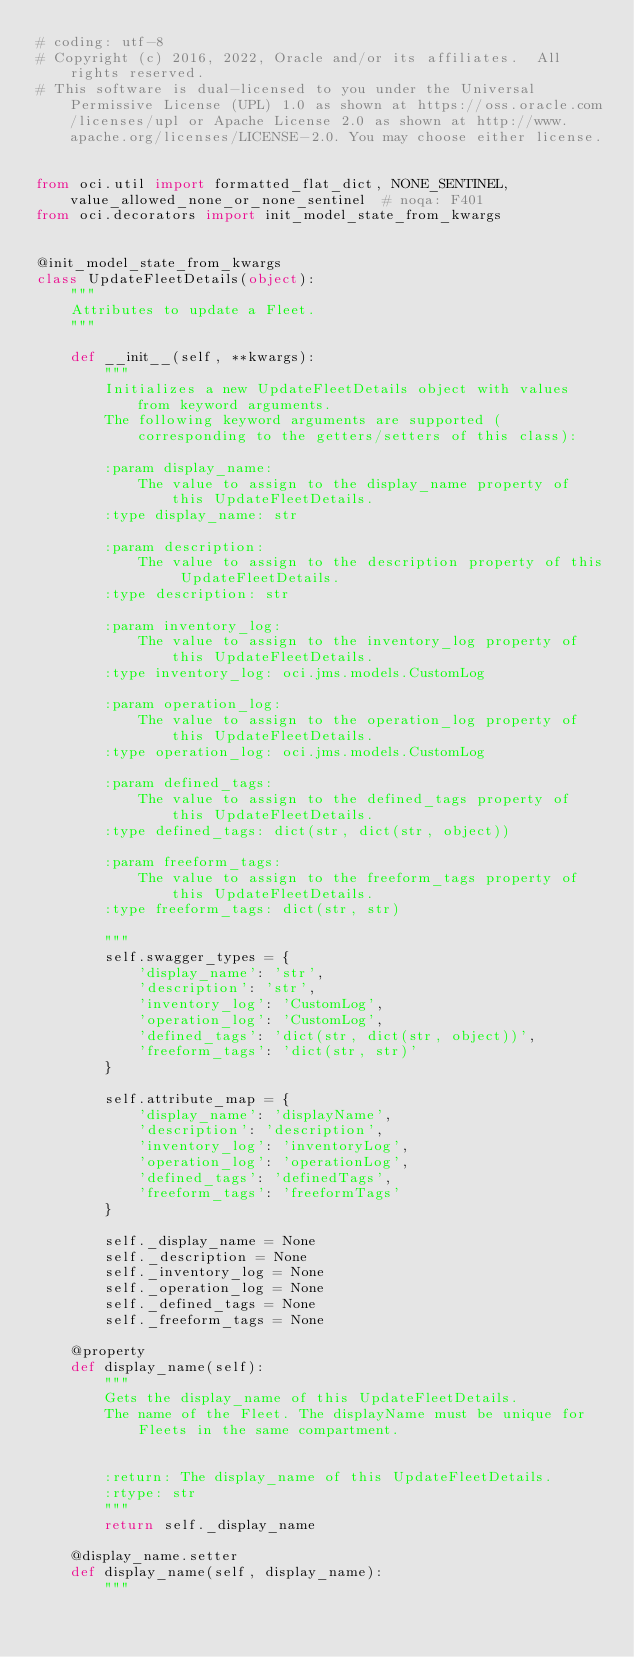<code> <loc_0><loc_0><loc_500><loc_500><_Python_># coding: utf-8
# Copyright (c) 2016, 2022, Oracle and/or its affiliates.  All rights reserved.
# This software is dual-licensed to you under the Universal Permissive License (UPL) 1.0 as shown at https://oss.oracle.com/licenses/upl or Apache License 2.0 as shown at http://www.apache.org/licenses/LICENSE-2.0. You may choose either license.


from oci.util import formatted_flat_dict, NONE_SENTINEL, value_allowed_none_or_none_sentinel  # noqa: F401
from oci.decorators import init_model_state_from_kwargs


@init_model_state_from_kwargs
class UpdateFleetDetails(object):
    """
    Attributes to update a Fleet.
    """

    def __init__(self, **kwargs):
        """
        Initializes a new UpdateFleetDetails object with values from keyword arguments.
        The following keyword arguments are supported (corresponding to the getters/setters of this class):

        :param display_name:
            The value to assign to the display_name property of this UpdateFleetDetails.
        :type display_name: str

        :param description:
            The value to assign to the description property of this UpdateFleetDetails.
        :type description: str

        :param inventory_log:
            The value to assign to the inventory_log property of this UpdateFleetDetails.
        :type inventory_log: oci.jms.models.CustomLog

        :param operation_log:
            The value to assign to the operation_log property of this UpdateFleetDetails.
        :type operation_log: oci.jms.models.CustomLog

        :param defined_tags:
            The value to assign to the defined_tags property of this UpdateFleetDetails.
        :type defined_tags: dict(str, dict(str, object))

        :param freeform_tags:
            The value to assign to the freeform_tags property of this UpdateFleetDetails.
        :type freeform_tags: dict(str, str)

        """
        self.swagger_types = {
            'display_name': 'str',
            'description': 'str',
            'inventory_log': 'CustomLog',
            'operation_log': 'CustomLog',
            'defined_tags': 'dict(str, dict(str, object))',
            'freeform_tags': 'dict(str, str)'
        }

        self.attribute_map = {
            'display_name': 'displayName',
            'description': 'description',
            'inventory_log': 'inventoryLog',
            'operation_log': 'operationLog',
            'defined_tags': 'definedTags',
            'freeform_tags': 'freeformTags'
        }

        self._display_name = None
        self._description = None
        self._inventory_log = None
        self._operation_log = None
        self._defined_tags = None
        self._freeform_tags = None

    @property
    def display_name(self):
        """
        Gets the display_name of this UpdateFleetDetails.
        The name of the Fleet. The displayName must be unique for Fleets in the same compartment.


        :return: The display_name of this UpdateFleetDetails.
        :rtype: str
        """
        return self._display_name

    @display_name.setter
    def display_name(self, display_name):
        """</code> 